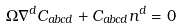Convert formula to latex. <formula><loc_0><loc_0><loc_500><loc_500>\Omega \nabla ^ { d } C _ { a b c d } + C _ { a b c d } n ^ { d } = 0</formula> 